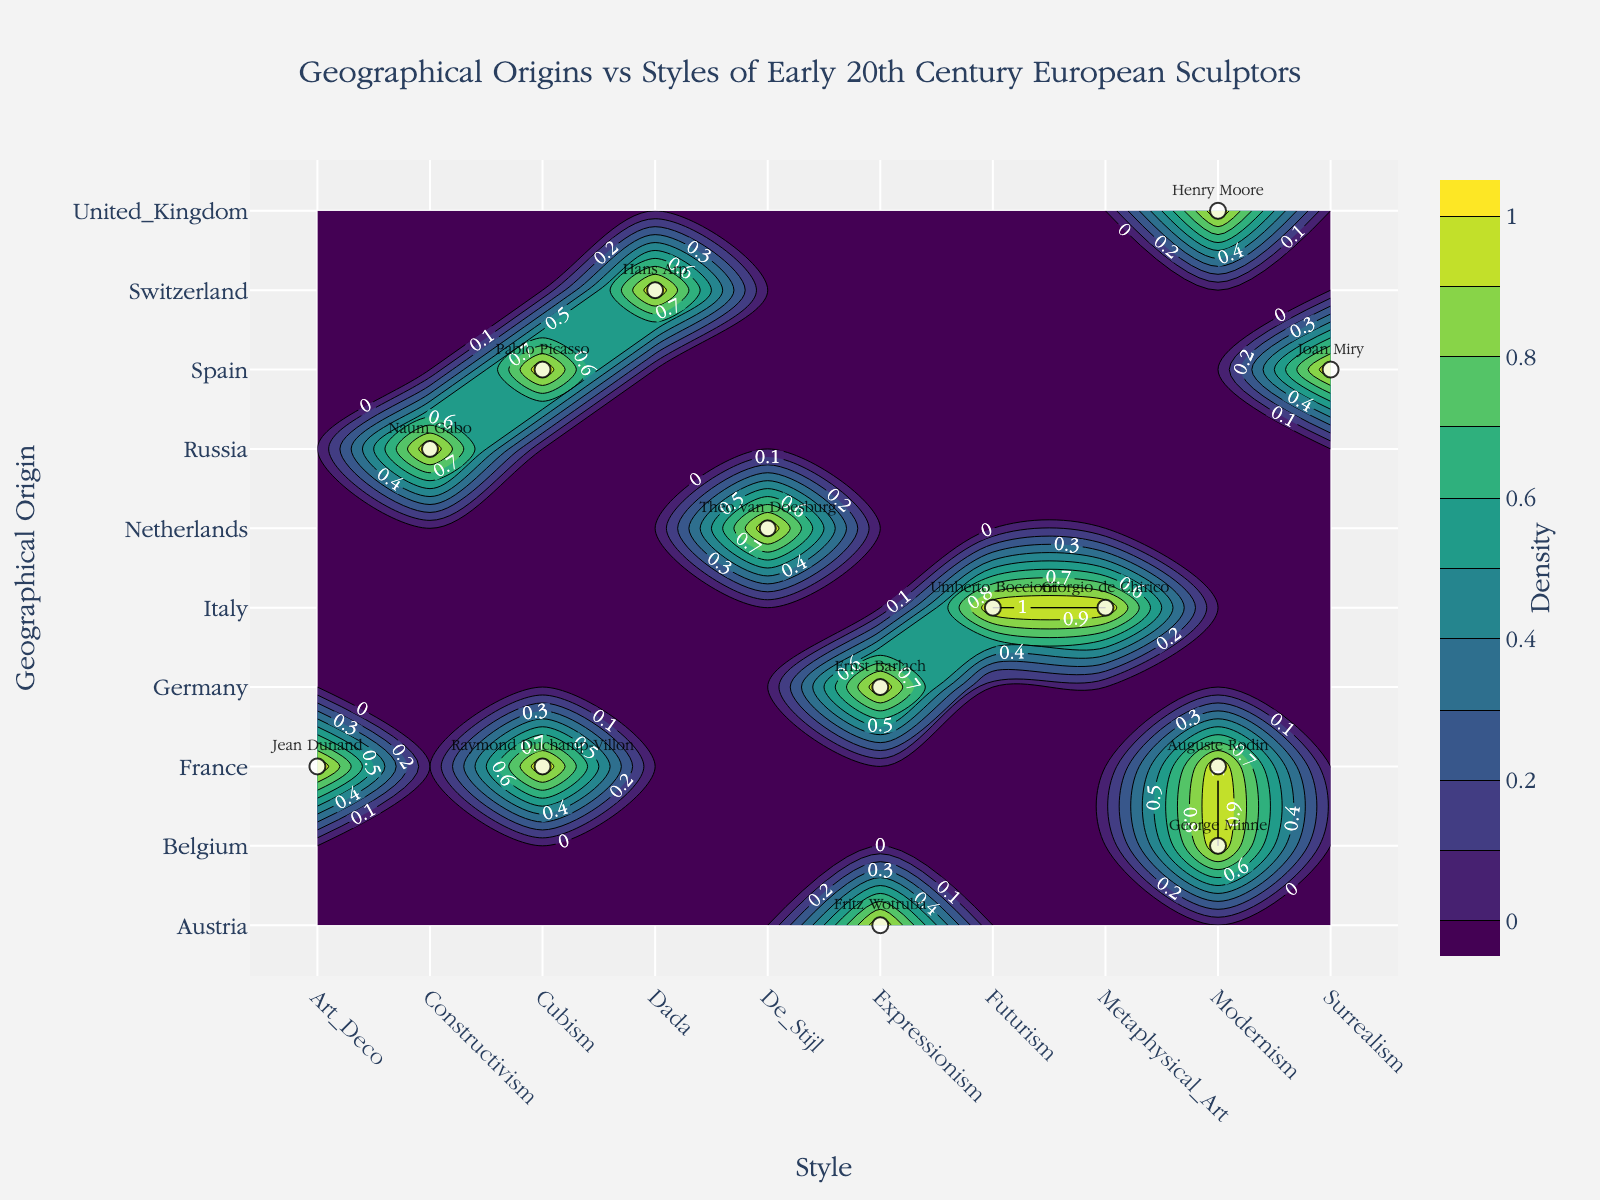What is the title of the plot? The title is usually at the top of the plot. In this case, it says: "Geographical Origins vs Styles of Early 20th Century European Sculptors"
Answer: Geographical Origins vs Styles of Early 20th Century European Sculptors Which geographical origin featured in the plot has the most diverse styles of sculpture? By examining the y-axis, we can see the geographical origins, and by counting the number of different styles (or x-axis points) each origin has, we find that France and Italy both have multiple styles listed.
Answer: France and Italy What style is associated with Ernst Barlach? To find the style associated with Ernst Barlach, look for his name in the scatter plot data points and check the corresponding x-coordinate which represents styles.
Answer: Expressionism Which countries have sculptors listed in the Dada movement? Look at the Dada style on the x-axis and check the points on the y-axis that intersect this style to identify the countries.
Answer: Switzerland Count the different styles associated with France. By inspecting the y-coordinate for France, count how many different x-coordinates (styles) France uses.
Answer: Four Is there any sculptor associated with Art Deco? If so, who is it? Check the x-axis for the Art Deco style and see if there’s a marker with a sculptor's name at that position.
Answer: Jean Dunand Between Italy and Spain, which country has more styles represented? Count the different x-coordinates (styles) for Italy and Spain by looking at their y-coordinates and comparing them. Italy has Futurism and Metaphysical Art, while Spain has Cubism and Surrealism. Both have the same number of styles.
Answer: Both have two styles What style of sculpture is Umberto Boccioni known for? Locate Umberto Boccioni on the scatter plot and check his corresponding x-coordinate, which should give the style name.
Answer: Futurism How many sculptors are listed for the United Kingdom? Check the y-coordinate for the United Kingdom and count each distinct marker/text associated with it.
Answer: One (Henry Moore) Which style on the x-axis has the highest number of associated geographical origins? Inspect the x-axis and count how many points it intersects with for each style. Cubism (France and Spain) has multiple origins.
Answer: Cubism 